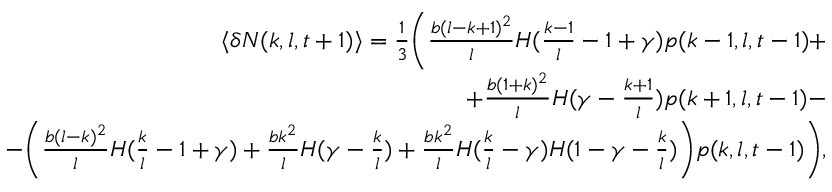<formula> <loc_0><loc_0><loc_500><loc_500>\begin{array} { r } { \langle \delta N ( k , l , t + 1 ) \rangle = \frac { 1 } { 3 } \left ( \frac { b ( l - k + 1 ) ^ { 2 } } { l } H ( \frac { k - 1 } { l } - 1 + \gamma ) p ( k - 1 , l , t - 1 ) + } \\ { + \frac { b ( 1 + k ) ^ { 2 } } { l } H ( \gamma - \frac { k + 1 } { l } ) p ( k + 1 , l , t - 1 ) - } \\ { - \left ( \frac { b ( l - k ) ^ { 2 } } { l } H ( \frac { k } { l } - 1 + \gamma ) + \frac { b k ^ { 2 } } { l } H ( \gamma - \frac { k } { l } ) + \frac { b k ^ { 2 } } { l } H ( \frac { k } { l } - \gamma ) H ( 1 - \gamma - \frac { k } { l } ) \right ) p ( k , l , t - 1 ) \right ) , } \end{array}</formula> 